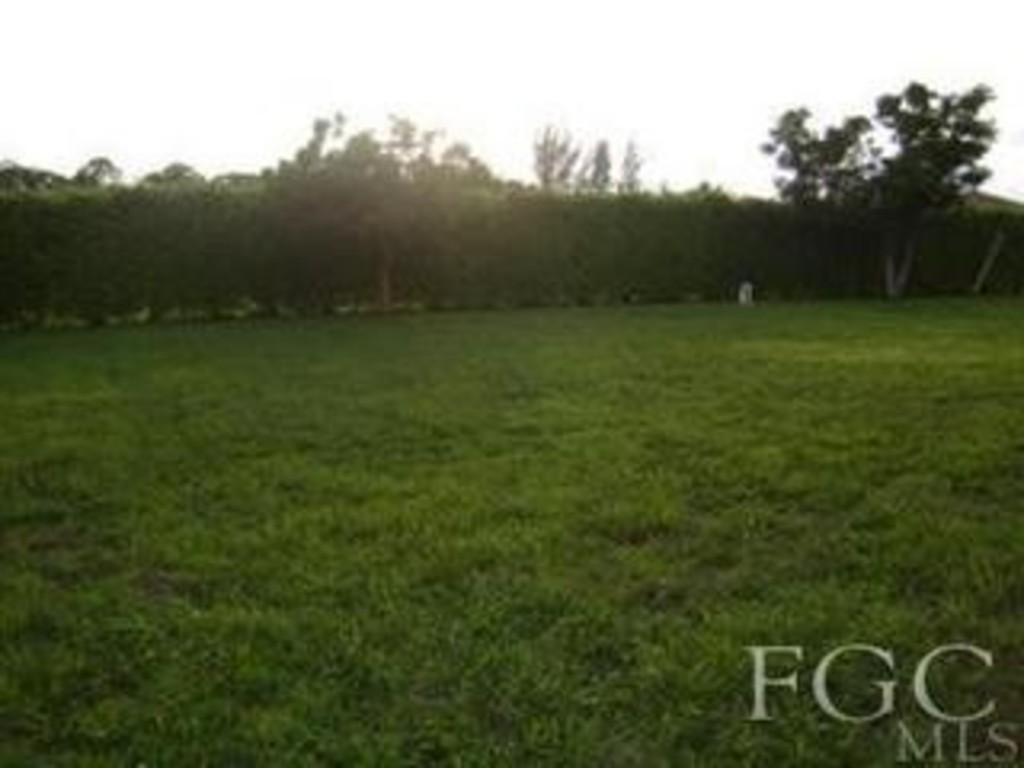What type of vegetation is present on the grassland in the image? There are trees on the grassland in the image. Where is the text located in the image? The text is located at the right bottom of the image. What can be seen at the top of the image? The sky is visible at the top of the image. What type of trousers are being worn by the trees in the image? There are no trousers present in the image, as trees do not wear clothing. How is the steam generated in the image? There is no steam present in the image. 